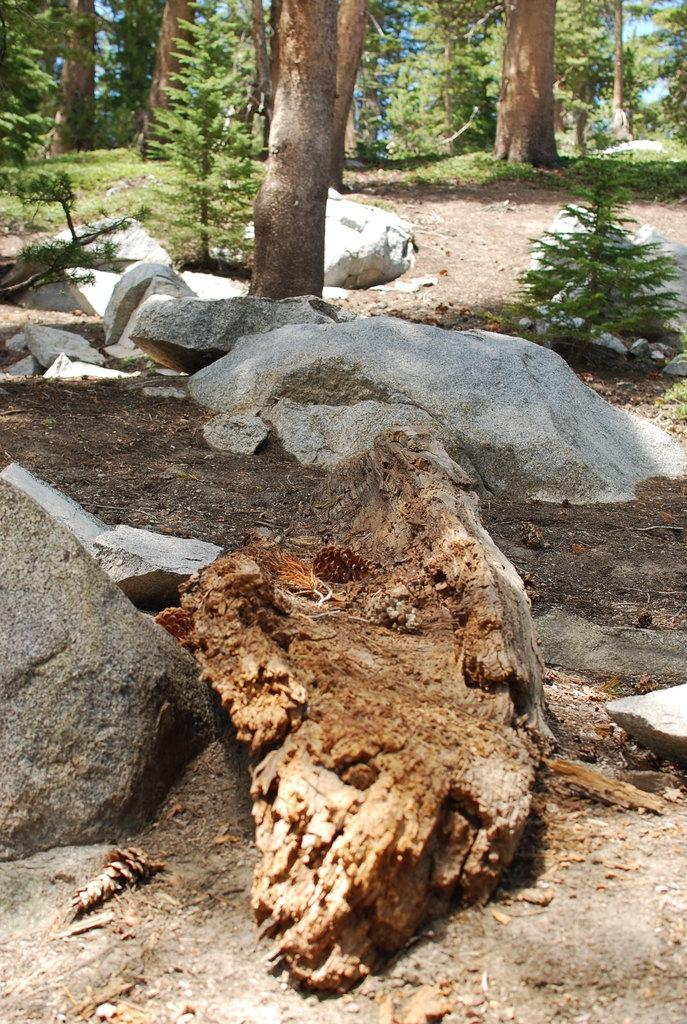What object is the main focus of the image? There is a trunk in the image. What can be seen in the background of the image? There are rocks and trees with green color in the background of the image. What type of print can be seen on the trunk in the image? There is no print visible on the trunk in the image. Can you see a pipe coming out of the trunk in the image? There is no pipe present in the image. 